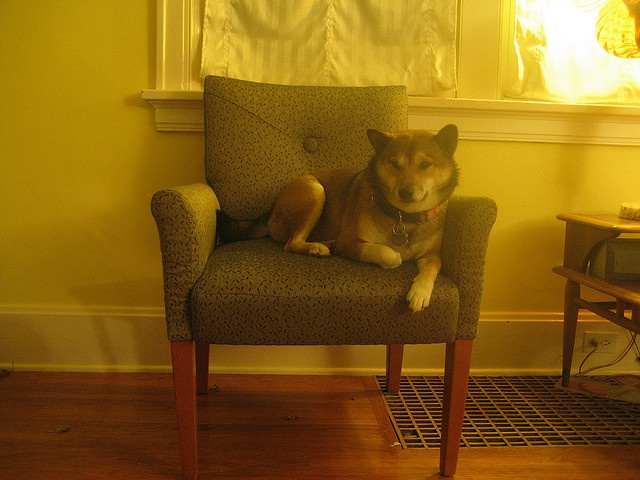Describe the objects in this image and their specific colors. I can see chair in olive, maroon, and black tones and dog in olive, maroon, and black tones in this image. 